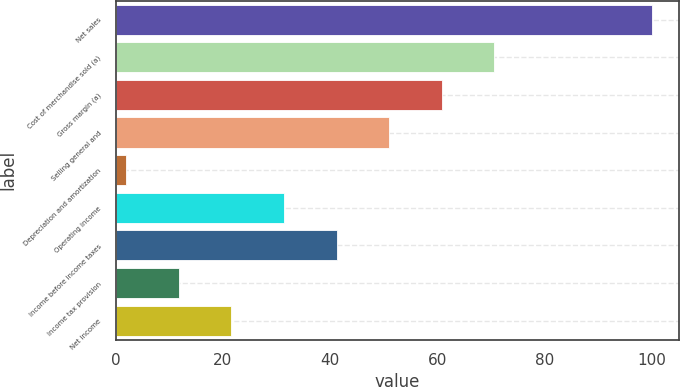<chart> <loc_0><loc_0><loc_500><loc_500><bar_chart><fcel>Net sales<fcel>Cost of merchandise sold (a)<fcel>Gross margin (a)<fcel>Selling general and<fcel>Depreciation and amortization<fcel>Operating income<fcel>Income before income taxes<fcel>Income tax provision<fcel>Net income<nl><fcel>100<fcel>70.6<fcel>60.8<fcel>51<fcel>2<fcel>31.4<fcel>41.2<fcel>11.8<fcel>21.6<nl></chart> 